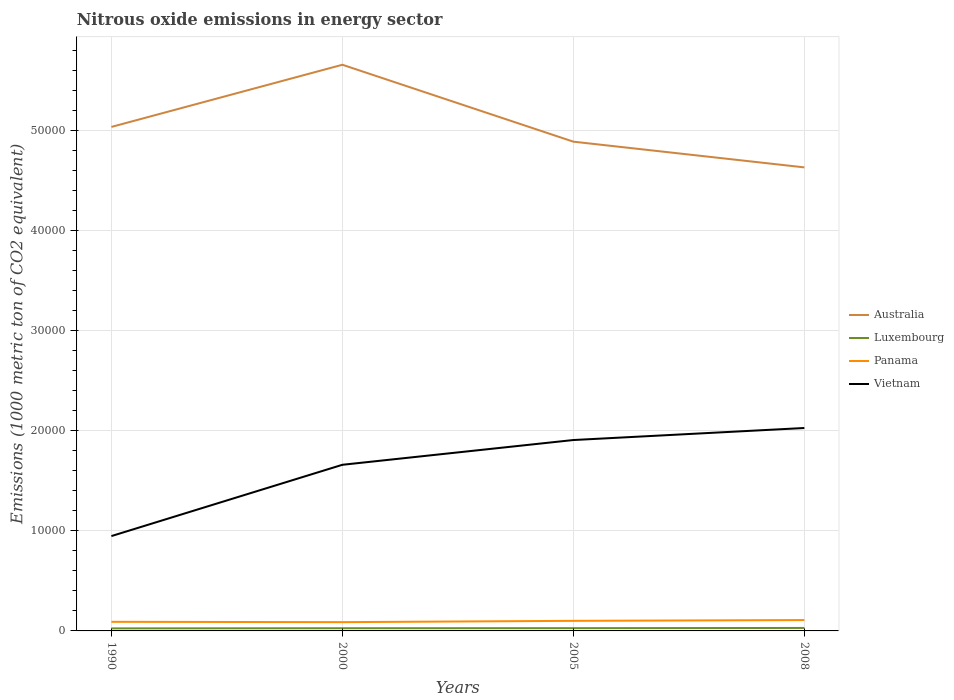How many different coloured lines are there?
Your answer should be very brief. 4. Does the line corresponding to Luxembourg intersect with the line corresponding to Australia?
Provide a succinct answer. No. Is the number of lines equal to the number of legend labels?
Your answer should be compact. Yes. Across all years, what is the maximum amount of nitrous oxide emitted in Luxembourg?
Give a very brief answer. 253.6. What is the total amount of nitrous oxide emitted in Panama in the graph?
Give a very brief answer. -206.5. What is the difference between the highest and the second highest amount of nitrous oxide emitted in Vietnam?
Ensure brevity in your answer.  1.08e+04. What is the difference between the highest and the lowest amount of nitrous oxide emitted in Vietnam?
Provide a succinct answer. 3. Is the amount of nitrous oxide emitted in Panama strictly greater than the amount of nitrous oxide emitted in Luxembourg over the years?
Provide a short and direct response. No. Are the values on the major ticks of Y-axis written in scientific E-notation?
Your response must be concise. No. How are the legend labels stacked?
Offer a terse response. Vertical. What is the title of the graph?
Your answer should be very brief. Nitrous oxide emissions in energy sector. What is the label or title of the Y-axis?
Provide a short and direct response. Emissions (1000 metric ton of CO2 equivalent). What is the Emissions (1000 metric ton of CO2 equivalent) in Australia in 1990?
Ensure brevity in your answer.  5.04e+04. What is the Emissions (1000 metric ton of CO2 equivalent) in Luxembourg in 1990?
Make the answer very short. 253.6. What is the Emissions (1000 metric ton of CO2 equivalent) in Panama in 1990?
Your answer should be compact. 910.4. What is the Emissions (1000 metric ton of CO2 equivalent) of Vietnam in 1990?
Offer a very short reply. 9479.8. What is the Emissions (1000 metric ton of CO2 equivalent) of Australia in 2000?
Keep it short and to the point. 5.66e+04. What is the Emissions (1000 metric ton of CO2 equivalent) of Luxembourg in 2000?
Your answer should be very brief. 268.4. What is the Emissions (1000 metric ton of CO2 equivalent) in Panama in 2000?
Provide a succinct answer. 878.4. What is the Emissions (1000 metric ton of CO2 equivalent) in Vietnam in 2000?
Your answer should be very brief. 1.66e+04. What is the Emissions (1000 metric ton of CO2 equivalent) of Australia in 2005?
Make the answer very short. 4.89e+04. What is the Emissions (1000 metric ton of CO2 equivalent) in Luxembourg in 2005?
Ensure brevity in your answer.  275.3. What is the Emissions (1000 metric ton of CO2 equivalent) in Panama in 2005?
Offer a very short reply. 1006.8. What is the Emissions (1000 metric ton of CO2 equivalent) in Vietnam in 2005?
Offer a very short reply. 1.91e+04. What is the Emissions (1000 metric ton of CO2 equivalent) of Australia in 2008?
Provide a short and direct response. 4.63e+04. What is the Emissions (1000 metric ton of CO2 equivalent) in Luxembourg in 2008?
Offer a very short reply. 296.2. What is the Emissions (1000 metric ton of CO2 equivalent) in Panama in 2008?
Your response must be concise. 1084.9. What is the Emissions (1000 metric ton of CO2 equivalent) of Vietnam in 2008?
Make the answer very short. 2.03e+04. Across all years, what is the maximum Emissions (1000 metric ton of CO2 equivalent) of Australia?
Provide a short and direct response. 5.66e+04. Across all years, what is the maximum Emissions (1000 metric ton of CO2 equivalent) of Luxembourg?
Ensure brevity in your answer.  296.2. Across all years, what is the maximum Emissions (1000 metric ton of CO2 equivalent) in Panama?
Ensure brevity in your answer.  1084.9. Across all years, what is the maximum Emissions (1000 metric ton of CO2 equivalent) in Vietnam?
Ensure brevity in your answer.  2.03e+04. Across all years, what is the minimum Emissions (1000 metric ton of CO2 equivalent) in Australia?
Ensure brevity in your answer.  4.63e+04. Across all years, what is the minimum Emissions (1000 metric ton of CO2 equivalent) in Luxembourg?
Keep it short and to the point. 253.6. Across all years, what is the minimum Emissions (1000 metric ton of CO2 equivalent) in Panama?
Make the answer very short. 878.4. Across all years, what is the minimum Emissions (1000 metric ton of CO2 equivalent) in Vietnam?
Your answer should be compact. 9479.8. What is the total Emissions (1000 metric ton of CO2 equivalent) of Australia in the graph?
Provide a short and direct response. 2.02e+05. What is the total Emissions (1000 metric ton of CO2 equivalent) in Luxembourg in the graph?
Your answer should be compact. 1093.5. What is the total Emissions (1000 metric ton of CO2 equivalent) in Panama in the graph?
Your answer should be very brief. 3880.5. What is the total Emissions (1000 metric ton of CO2 equivalent) of Vietnam in the graph?
Your answer should be compact. 6.55e+04. What is the difference between the Emissions (1000 metric ton of CO2 equivalent) of Australia in 1990 and that in 2000?
Give a very brief answer. -6212.8. What is the difference between the Emissions (1000 metric ton of CO2 equivalent) in Luxembourg in 1990 and that in 2000?
Provide a short and direct response. -14.8. What is the difference between the Emissions (1000 metric ton of CO2 equivalent) of Vietnam in 1990 and that in 2000?
Offer a very short reply. -7126.8. What is the difference between the Emissions (1000 metric ton of CO2 equivalent) in Australia in 1990 and that in 2005?
Your response must be concise. 1475.2. What is the difference between the Emissions (1000 metric ton of CO2 equivalent) in Luxembourg in 1990 and that in 2005?
Offer a terse response. -21.7. What is the difference between the Emissions (1000 metric ton of CO2 equivalent) in Panama in 1990 and that in 2005?
Offer a terse response. -96.4. What is the difference between the Emissions (1000 metric ton of CO2 equivalent) in Vietnam in 1990 and that in 2005?
Keep it short and to the point. -9601.2. What is the difference between the Emissions (1000 metric ton of CO2 equivalent) in Australia in 1990 and that in 2008?
Keep it short and to the point. 4045.5. What is the difference between the Emissions (1000 metric ton of CO2 equivalent) of Luxembourg in 1990 and that in 2008?
Your answer should be compact. -42.6. What is the difference between the Emissions (1000 metric ton of CO2 equivalent) of Panama in 1990 and that in 2008?
Provide a short and direct response. -174.5. What is the difference between the Emissions (1000 metric ton of CO2 equivalent) in Vietnam in 1990 and that in 2008?
Keep it short and to the point. -1.08e+04. What is the difference between the Emissions (1000 metric ton of CO2 equivalent) in Australia in 2000 and that in 2005?
Keep it short and to the point. 7688. What is the difference between the Emissions (1000 metric ton of CO2 equivalent) in Luxembourg in 2000 and that in 2005?
Keep it short and to the point. -6.9. What is the difference between the Emissions (1000 metric ton of CO2 equivalent) in Panama in 2000 and that in 2005?
Provide a succinct answer. -128.4. What is the difference between the Emissions (1000 metric ton of CO2 equivalent) of Vietnam in 2000 and that in 2005?
Keep it short and to the point. -2474.4. What is the difference between the Emissions (1000 metric ton of CO2 equivalent) of Australia in 2000 and that in 2008?
Provide a succinct answer. 1.03e+04. What is the difference between the Emissions (1000 metric ton of CO2 equivalent) of Luxembourg in 2000 and that in 2008?
Provide a succinct answer. -27.8. What is the difference between the Emissions (1000 metric ton of CO2 equivalent) of Panama in 2000 and that in 2008?
Provide a short and direct response. -206.5. What is the difference between the Emissions (1000 metric ton of CO2 equivalent) in Vietnam in 2000 and that in 2008?
Provide a succinct answer. -3676.6. What is the difference between the Emissions (1000 metric ton of CO2 equivalent) in Australia in 2005 and that in 2008?
Make the answer very short. 2570.3. What is the difference between the Emissions (1000 metric ton of CO2 equivalent) in Luxembourg in 2005 and that in 2008?
Give a very brief answer. -20.9. What is the difference between the Emissions (1000 metric ton of CO2 equivalent) in Panama in 2005 and that in 2008?
Offer a very short reply. -78.1. What is the difference between the Emissions (1000 metric ton of CO2 equivalent) of Vietnam in 2005 and that in 2008?
Provide a succinct answer. -1202.2. What is the difference between the Emissions (1000 metric ton of CO2 equivalent) of Australia in 1990 and the Emissions (1000 metric ton of CO2 equivalent) of Luxembourg in 2000?
Offer a very short reply. 5.01e+04. What is the difference between the Emissions (1000 metric ton of CO2 equivalent) in Australia in 1990 and the Emissions (1000 metric ton of CO2 equivalent) in Panama in 2000?
Your answer should be very brief. 4.95e+04. What is the difference between the Emissions (1000 metric ton of CO2 equivalent) in Australia in 1990 and the Emissions (1000 metric ton of CO2 equivalent) in Vietnam in 2000?
Offer a terse response. 3.38e+04. What is the difference between the Emissions (1000 metric ton of CO2 equivalent) in Luxembourg in 1990 and the Emissions (1000 metric ton of CO2 equivalent) in Panama in 2000?
Provide a short and direct response. -624.8. What is the difference between the Emissions (1000 metric ton of CO2 equivalent) of Luxembourg in 1990 and the Emissions (1000 metric ton of CO2 equivalent) of Vietnam in 2000?
Your response must be concise. -1.64e+04. What is the difference between the Emissions (1000 metric ton of CO2 equivalent) in Panama in 1990 and the Emissions (1000 metric ton of CO2 equivalent) in Vietnam in 2000?
Your answer should be very brief. -1.57e+04. What is the difference between the Emissions (1000 metric ton of CO2 equivalent) of Australia in 1990 and the Emissions (1000 metric ton of CO2 equivalent) of Luxembourg in 2005?
Provide a short and direct response. 5.01e+04. What is the difference between the Emissions (1000 metric ton of CO2 equivalent) in Australia in 1990 and the Emissions (1000 metric ton of CO2 equivalent) in Panama in 2005?
Keep it short and to the point. 4.94e+04. What is the difference between the Emissions (1000 metric ton of CO2 equivalent) of Australia in 1990 and the Emissions (1000 metric ton of CO2 equivalent) of Vietnam in 2005?
Your response must be concise. 3.13e+04. What is the difference between the Emissions (1000 metric ton of CO2 equivalent) in Luxembourg in 1990 and the Emissions (1000 metric ton of CO2 equivalent) in Panama in 2005?
Your answer should be very brief. -753.2. What is the difference between the Emissions (1000 metric ton of CO2 equivalent) of Luxembourg in 1990 and the Emissions (1000 metric ton of CO2 equivalent) of Vietnam in 2005?
Make the answer very short. -1.88e+04. What is the difference between the Emissions (1000 metric ton of CO2 equivalent) of Panama in 1990 and the Emissions (1000 metric ton of CO2 equivalent) of Vietnam in 2005?
Give a very brief answer. -1.82e+04. What is the difference between the Emissions (1000 metric ton of CO2 equivalent) of Australia in 1990 and the Emissions (1000 metric ton of CO2 equivalent) of Luxembourg in 2008?
Your answer should be very brief. 5.01e+04. What is the difference between the Emissions (1000 metric ton of CO2 equivalent) of Australia in 1990 and the Emissions (1000 metric ton of CO2 equivalent) of Panama in 2008?
Provide a succinct answer. 4.93e+04. What is the difference between the Emissions (1000 metric ton of CO2 equivalent) of Australia in 1990 and the Emissions (1000 metric ton of CO2 equivalent) of Vietnam in 2008?
Your response must be concise. 3.01e+04. What is the difference between the Emissions (1000 metric ton of CO2 equivalent) of Luxembourg in 1990 and the Emissions (1000 metric ton of CO2 equivalent) of Panama in 2008?
Offer a very short reply. -831.3. What is the difference between the Emissions (1000 metric ton of CO2 equivalent) of Luxembourg in 1990 and the Emissions (1000 metric ton of CO2 equivalent) of Vietnam in 2008?
Your answer should be very brief. -2.00e+04. What is the difference between the Emissions (1000 metric ton of CO2 equivalent) of Panama in 1990 and the Emissions (1000 metric ton of CO2 equivalent) of Vietnam in 2008?
Offer a very short reply. -1.94e+04. What is the difference between the Emissions (1000 metric ton of CO2 equivalent) in Australia in 2000 and the Emissions (1000 metric ton of CO2 equivalent) in Luxembourg in 2005?
Provide a short and direct response. 5.63e+04. What is the difference between the Emissions (1000 metric ton of CO2 equivalent) of Australia in 2000 and the Emissions (1000 metric ton of CO2 equivalent) of Panama in 2005?
Your response must be concise. 5.56e+04. What is the difference between the Emissions (1000 metric ton of CO2 equivalent) in Australia in 2000 and the Emissions (1000 metric ton of CO2 equivalent) in Vietnam in 2005?
Offer a very short reply. 3.75e+04. What is the difference between the Emissions (1000 metric ton of CO2 equivalent) in Luxembourg in 2000 and the Emissions (1000 metric ton of CO2 equivalent) in Panama in 2005?
Your answer should be compact. -738.4. What is the difference between the Emissions (1000 metric ton of CO2 equivalent) in Luxembourg in 2000 and the Emissions (1000 metric ton of CO2 equivalent) in Vietnam in 2005?
Your response must be concise. -1.88e+04. What is the difference between the Emissions (1000 metric ton of CO2 equivalent) of Panama in 2000 and the Emissions (1000 metric ton of CO2 equivalent) of Vietnam in 2005?
Provide a short and direct response. -1.82e+04. What is the difference between the Emissions (1000 metric ton of CO2 equivalent) of Australia in 2000 and the Emissions (1000 metric ton of CO2 equivalent) of Luxembourg in 2008?
Provide a short and direct response. 5.63e+04. What is the difference between the Emissions (1000 metric ton of CO2 equivalent) of Australia in 2000 and the Emissions (1000 metric ton of CO2 equivalent) of Panama in 2008?
Offer a terse response. 5.55e+04. What is the difference between the Emissions (1000 metric ton of CO2 equivalent) in Australia in 2000 and the Emissions (1000 metric ton of CO2 equivalent) in Vietnam in 2008?
Ensure brevity in your answer.  3.63e+04. What is the difference between the Emissions (1000 metric ton of CO2 equivalent) in Luxembourg in 2000 and the Emissions (1000 metric ton of CO2 equivalent) in Panama in 2008?
Offer a terse response. -816.5. What is the difference between the Emissions (1000 metric ton of CO2 equivalent) of Luxembourg in 2000 and the Emissions (1000 metric ton of CO2 equivalent) of Vietnam in 2008?
Provide a succinct answer. -2.00e+04. What is the difference between the Emissions (1000 metric ton of CO2 equivalent) of Panama in 2000 and the Emissions (1000 metric ton of CO2 equivalent) of Vietnam in 2008?
Offer a terse response. -1.94e+04. What is the difference between the Emissions (1000 metric ton of CO2 equivalent) of Australia in 2005 and the Emissions (1000 metric ton of CO2 equivalent) of Luxembourg in 2008?
Offer a very short reply. 4.86e+04. What is the difference between the Emissions (1000 metric ton of CO2 equivalent) of Australia in 2005 and the Emissions (1000 metric ton of CO2 equivalent) of Panama in 2008?
Give a very brief answer. 4.78e+04. What is the difference between the Emissions (1000 metric ton of CO2 equivalent) of Australia in 2005 and the Emissions (1000 metric ton of CO2 equivalent) of Vietnam in 2008?
Give a very brief answer. 2.86e+04. What is the difference between the Emissions (1000 metric ton of CO2 equivalent) in Luxembourg in 2005 and the Emissions (1000 metric ton of CO2 equivalent) in Panama in 2008?
Ensure brevity in your answer.  -809.6. What is the difference between the Emissions (1000 metric ton of CO2 equivalent) of Luxembourg in 2005 and the Emissions (1000 metric ton of CO2 equivalent) of Vietnam in 2008?
Offer a very short reply. -2.00e+04. What is the difference between the Emissions (1000 metric ton of CO2 equivalent) in Panama in 2005 and the Emissions (1000 metric ton of CO2 equivalent) in Vietnam in 2008?
Offer a terse response. -1.93e+04. What is the average Emissions (1000 metric ton of CO2 equivalent) in Australia per year?
Ensure brevity in your answer.  5.06e+04. What is the average Emissions (1000 metric ton of CO2 equivalent) of Luxembourg per year?
Ensure brevity in your answer.  273.38. What is the average Emissions (1000 metric ton of CO2 equivalent) in Panama per year?
Offer a terse response. 970.12. What is the average Emissions (1000 metric ton of CO2 equivalent) of Vietnam per year?
Keep it short and to the point. 1.64e+04. In the year 1990, what is the difference between the Emissions (1000 metric ton of CO2 equivalent) of Australia and Emissions (1000 metric ton of CO2 equivalent) of Luxembourg?
Your response must be concise. 5.01e+04. In the year 1990, what is the difference between the Emissions (1000 metric ton of CO2 equivalent) of Australia and Emissions (1000 metric ton of CO2 equivalent) of Panama?
Offer a terse response. 4.95e+04. In the year 1990, what is the difference between the Emissions (1000 metric ton of CO2 equivalent) in Australia and Emissions (1000 metric ton of CO2 equivalent) in Vietnam?
Your answer should be compact. 4.09e+04. In the year 1990, what is the difference between the Emissions (1000 metric ton of CO2 equivalent) in Luxembourg and Emissions (1000 metric ton of CO2 equivalent) in Panama?
Provide a succinct answer. -656.8. In the year 1990, what is the difference between the Emissions (1000 metric ton of CO2 equivalent) in Luxembourg and Emissions (1000 metric ton of CO2 equivalent) in Vietnam?
Your answer should be compact. -9226.2. In the year 1990, what is the difference between the Emissions (1000 metric ton of CO2 equivalent) of Panama and Emissions (1000 metric ton of CO2 equivalent) of Vietnam?
Keep it short and to the point. -8569.4. In the year 2000, what is the difference between the Emissions (1000 metric ton of CO2 equivalent) in Australia and Emissions (1000 metric ton of CO2 equivalent) in Luxembourg?
Provide a short and direct response. 5.63e+04. In the year 2000, what is the difference between the Emissions (1000 metric ton of CO2 equivalent) of Australia and Emissions (1000 metric ton of CO2 equivalent) of Panama?
Keep it short and to the point. 5.57e+04. In the year 2000, what is the difference between the Emissions (1000 metric ton of CO2 equivalent) of Australia and Emissions (1000 metric ton of CO2 equivalent) of Vietnam?
Offer a very short reply. 4.00e+04. In the year 2000, what is the difference between the Emissions (1000 metric ton of CO2 equivalent) in Luxembourg and Emissions (1000 metric ton of CO2 equivalent) in Panama?
Give a very brief answer. -610. In the year 2000, what is the difference between the Emissions (1000 metric ton of CO2 equivalent) in Luxembourg and Emissions (1000 metric ton of CO2 equivalent) in Vietnam?
Provide a succinct answer. -1.63e+04. In the year 2000, what is the difference between the Emissions (1000 metric ton of CO2 equivalent) in Panama and Emissions (1000 metric ton of CO2 equivalent) in Vietnam?
Provide a succinct answer. -1.57e+04. In the year 2005, what is the difference between the Emissions (1000 metric ton of CO2 equivalent) of Australia and Emissions (1000 metric ton of CO2 equivalent) of Luxembourg?
Your answer should be compact. 4.86e+04. In the year 2005, what is the difference between the Emissions (1000 metric ton of CO2 equivalent) of Australia and Emissions (1000 metric ton of CO2 equivalent) of Panama?
Provide a succinct answer. 4.79e+04. In the year 2005, what is the difference between the Emissions (1000 metric ton of CO2 equivalent) in Australia and Emissions (1000 metric ton of CO2 equivalent) in Vietnam?
Offer a terse response. 2.98e+04. In the year 2005, what is the difference between the Emissions (1000 metric ton of CO2 equivalent) of Luxembourg and Emissions (1000 metric ton of CO2 equivalent) of Panama?
Provide a succinct answer. -731.5. In the year 2005, what is the difference between the Emissions (1000 metric ton of CO2 equivalent) in Luxembourg and Emissions (1000 metric ton of CO2 equivalent) in Vietnam?
Ensure brevity in your answer.  -1.88e+04. In the year 2005, what is the difference between the Emissions (1000 metric ton of CO2 equivalent) in Panama and Emissions (1000 metric ton of CO2 equivalent) in Vietnam?
Your answer should be very brief. -1.81e+04. In the year 2008, what is the difference between the Emissions (1000 metric ton of CO2 equivalent) of Australia and Emissions (1000 metric ton of CO2 equivalent) of Luxembourg?
Your response must be concise. 4.60e+04. In the year 2008, what is the difference between the Emissions (1000 metric ton of CO2 equivalent) of Australia and Emissions (1000 metric ton of CO2 equivalent) of Panama?
Ensure brevity in your answer.  4.52e+04. In the year 2008, what is the difference between the Emissions (1000 metric ton of CO2 equivalent) of Australia and Emissions (1000 metric ton of CO2 equivalent) of Vietnam?
Provide a short and direct response. 2.60e+04. In the year 2008, what is the difference between the Emissions (1000 metric ton of CO2 equivalent) of Luxembourg and Emissions (1000 metric ton of CO2 equivalent) of Panama?
Offer a very short reply. -788.7. In the year 2008, what is the difference between the Emissions (1000 metric ton of CO2 equivalent) of Luxembourg and Emissions (1000 metric ton of CO2 equivalent) of Vietnam?
Keep it short and to the point. -2.00e+04. In the year 2008, what is the difference between the Emissions (1000 metric ton of CO2 equivalent) of Panama and Emissions (1000 metric ton of CO2 equivalent) of Vietnam?
Keep it short and to the point. -1.92e+04. What is the ratio of the Emissions (1000 metric ton of CO2 equivalent) in Australia in 1990 to that in 2000?
Keep it short and to the point. 0.89. What is the ratio of the Emissions (1000 metric ton of CO2 equivalent) of Luxembourg in 1990 to that in 2000?
Your answer should be compact. 0.94. What is the ratio of the Emissions (1000 metric ton of CO2 equivalent) in Panama in 1990 to that in 2000?
Offer a terse response. 1.04. What is the ratio of the Emissions (1000 metric ton of CO2 equivalent) of Vietnam in 1990 to that in 2000?
Your response must be concise. 0.57. What is the ratio of the Emissions (1000 metric ton of CO2 equivalent) in Australia in 1990 to that in 2005?
Offer a very short reply. 1.03. What is the ratio of the Emissions (1000 metric ton of CO2 equivalent) in Luxembourg in 1990 to that in 2005?
Provide a short and direct response. 0.92. What is the ratio of the Emissions (1000 metric ton of CO2 equivalent) of Panama in 1990 to that in 2005?
Your answer should be compact. 0.9. What is the ratio of the Emissions (1000 metric ton of CO2 equivalent) in Vietnam in 1990 to that in 2005?
Your response must be concise. 0.5. What is the ratio of the Emissions (1000 metric ton of CO2 equivalent) in Australia in 1990 to that in 2008?
Offer a very short reply. 1.09. What is the ratio of the Emissions (1000 metric ton of CO2 equivalent) of Luxembourg in 1990 to that in 2008?
Offer a very short reply. 0.86. What is the ratio of the Emissions (1000 metric ton of CO2 equivalent) in Panama in 1990 to that in 2008?
Your answer should be compact. 0.84. What is the ratio of the Emissions (1000 metric ton of CO2 equivalent) in Vietnam in 1990 to that in 2008?
Provide a succinct answer. 0.47. What is the ratio of the Emissions (1000 metric ton of CO2 equivalent) of Australia in 2000 to that in 2005?
Provide a short and direct response. 1.16. What is the ratio of the Emissions (1000 metric ton of CO2 equivalent) of Luxembourg in 2000 to that in 2005?
Your answer should be very brief. 0.97. What is the ratio of the Emissions (1000 metric ton of CO2 equivalent) in Panama in 2000 to that in 2005?
Keep it short and to the point. 0.87. What is the ratio of the Emissions (1000 metric ton of CO2 equivalent) in Vietnam in 2000 to that in 2005?
Your answer should be very brief. 0.87. What is the ratio of the Emissions (1000 metric ton of CO2 equivalent) in Australia in 2000 to that in 2008?
Make the answer very short. 1.22. What is the ratio of the Emissions (1000 metric ton of CO2 equivalent) in Luxembourg in 2000 to that in 2008?
Your response must be concise. 0.91. What is the ratio of the Emissions (1000 metric ton of CO2 equivalent) of Panama in 2000 to that in 2008?
Your response must be concise. 0.81. What is the ratio of the Emissions (1000 metric ton of CO2 equivalent) of Vietnam in 2000 to that in 2008?
Keep it short and to the point. 0.82. What is the ratio of the Emissions (1000 metric ton of CO2 equivalent) of Australia in 2005 to that in 2008?
Your answer should be very brief. 1.06. What is the ratio of the Emissions (1000 metric ton of CO2 equivalent) of Luxembourg in 2005 to that in 2008?
Offer a very short reply. 0.93. What is the ratio of the Emissions (1000 metric ton of CO2 equivalent) of Panama in 2005 to that in 2008?
Your response must be concise. 0.93. What is the ratio of the Emissions (1000 metric ton of CO2 equivalent) in Vietnam in 2005 to that in 2008?
Your answer should be compact. 0.94. What is the difference between the highest and the second highest Emissions (1000 metric ton of CO2 equivalent) of Australia?
Your answer should be very brief. 6212.8. What is the difference between the highest and the second highest Emissions (1000 metric ton of CO2 equivalent) in Luxembourg?
Keep it short and to the point. 20.9. What is the difference between the highest and the second highest Emissions (1000 metric ton of CO2 equivalent) of Panama?
Your response must be concise. 78.1. What is the difference between the highest and the second highest Emissions (1000 metric ton of CO2 equivalent) in Vietnam?
Keep it short and to the point. 1202.2. What is the difference between the highest and the lowest Emissions (1000 metric ton of CO2 equivalent) in Australia?
Make the answer very short. 1.03e+04. What is the difference between the highest and the lowest Emissions (1000 metric ton of CO2 equivalent) of Luxembourg?
Provide a short and direct response. 42.6. What is the difference between the highest and the lowest Emissions (1000 metric ton of CO2 equivalent) in Panama?
Your answer should be very brief. 206.5. What is the difference between the highest and the lowest Emissions (1000 metric ton of CO2 equivalent) of Vietnam?
Your answer should be compact. 1.08e+04. 